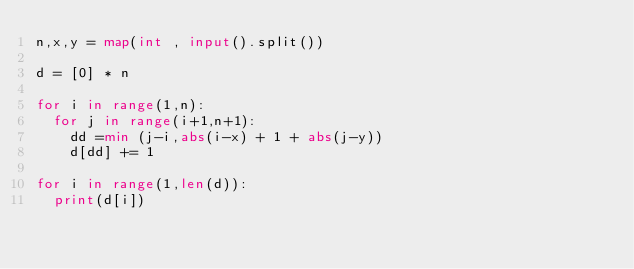<code> <loc_0><loc_0><loc_500><loc_500><_Python_>n,x,y = map(int , input().split())

d = [0] * n

for i in range(1,n):
  for j in range(i+1,n+1):
    dd =min (j-i,abs(i-x) + 1 + abs(j-y))
    d[dd] += 1

for i in range(1,len(d)):
  print(d[i])</code> 